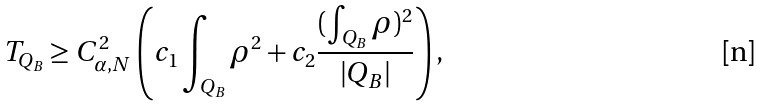<formula> <loc_0><loc_0><loc_500><loc_500>T _ { Q _ { B } } \geq C _ { \alpha , N } ^ { 2 } \left ( c _ { 1 } \int _ { Q _ { B } } \rho ^ { 2 } + c _ { 2 } \frac { ( \int _ { Q _ { B } } \rho ) ^ { 2 } } { | Q _ { B } | } \right ) ,</formula> 